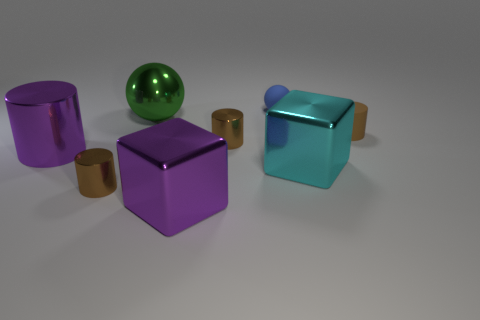Subtract all brown cylinders. How many were subtracted if there are1brown cylinders left? 2 Subtract all green blocks. How many brown cylinders are left? 3 Subtract 1 cylinders. How many cylinders are left? 3 Subtract all green cylinders. Subtract all cyan balls. How many cylinders are left? 4 Add 1 blue things. How many objects exist? 9 Subtract all balls. How many objects are left? 6 Subtract 0 green blocks. How many objects are left? 8 Subtract all big purple objects. Subtract all small brown rubber objects. How many objects are left? 5 Add 6 tiny blue spheres. How many tiny blue spheres are left? 7 Add 5 yellow rubber balls. How many yellow rubber balls exist? 5 